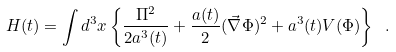<formula> <loc_0><loc_0><loc_500><loc_500>H ( t ) = \int d ^ { 3 } x \left \{ \frac { \Pi ^ { 2 } } { 2 a ^ { 3 } ( t ) } + \frac { a ( t ) } { 2 } ( \vec { \nabla } \Phi ) ^ { 2 } + a ^ { 3 } ( t ) V ( \Phi ) \right \} \ .</formula> 